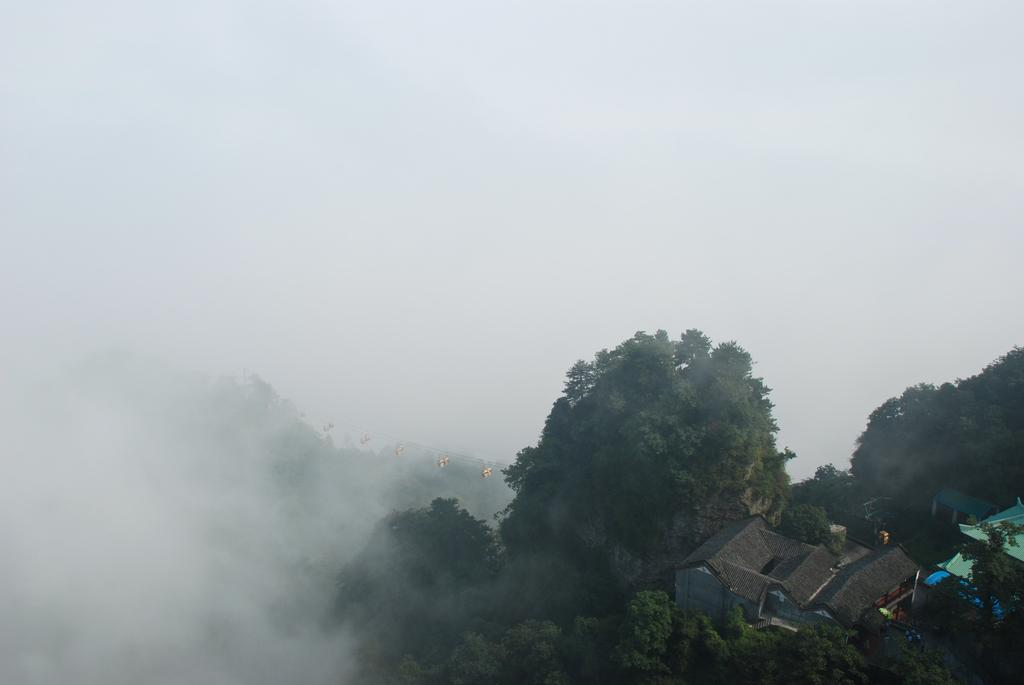What can be seen in the bottom right hand corner of the image? There are houses in the bottom right hand corner of the image. What is located near the houses? There are trees near the houses. What is the main feature of the background in the image? The background of the image is full of fog. What type of street is visible in the image? There is no street visible in the image; it primarily features houses, trees, and fog in the background. Who is the minister in charge of distributing the fog in the image? There is no minister or distribution of fog mentioned in the image; it is simply a natural atmospheric condition. 